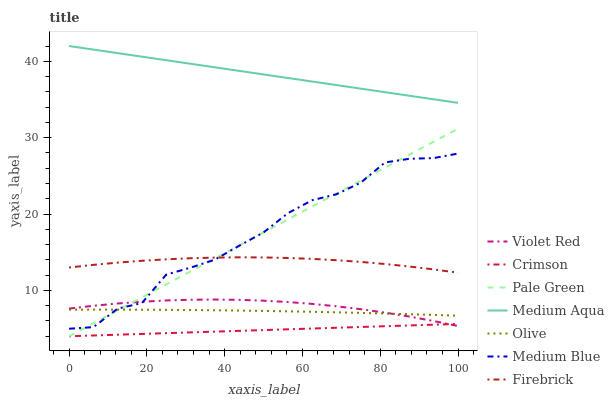Does Firebrick have the minimum area under the curve?
Answer yes or no. No. Does Firebrick have the maximum area under the curve?
Answer yes or no. No. Is Firebrick the smoothest?
Answer yes or no. No. Is Firebrick the roughest?
Answer yes or no. No. Does Firebrick have the lowest value?
Answer yes or no. No. Does Firebrick have the highest value?
Answer yes or no. No. Is Crimson less than Firebrick?
Answer yes or no. Yes. Is Firebrick greater than Crimson?
Answer yes or no. Yes. Does Crimson intersect Firebrick?
Answer yes or no. No. 